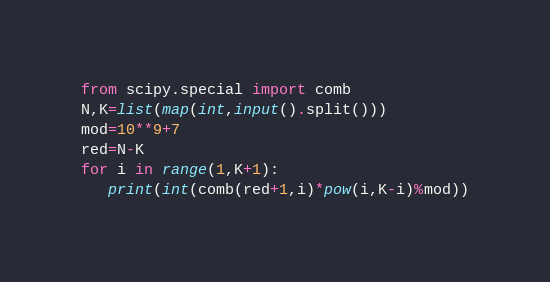Convert code to text. <code><loc_0><loc_0><loc_500><loc_500><_Python_>from scipy.special import comb
N,K=list(map(int,input().split()))
mod=10**9+7
red=N-K
for i in range(1,K+1):
   print(int(comb(red+1,i)*pow(i,K-i)%mod))</code> 